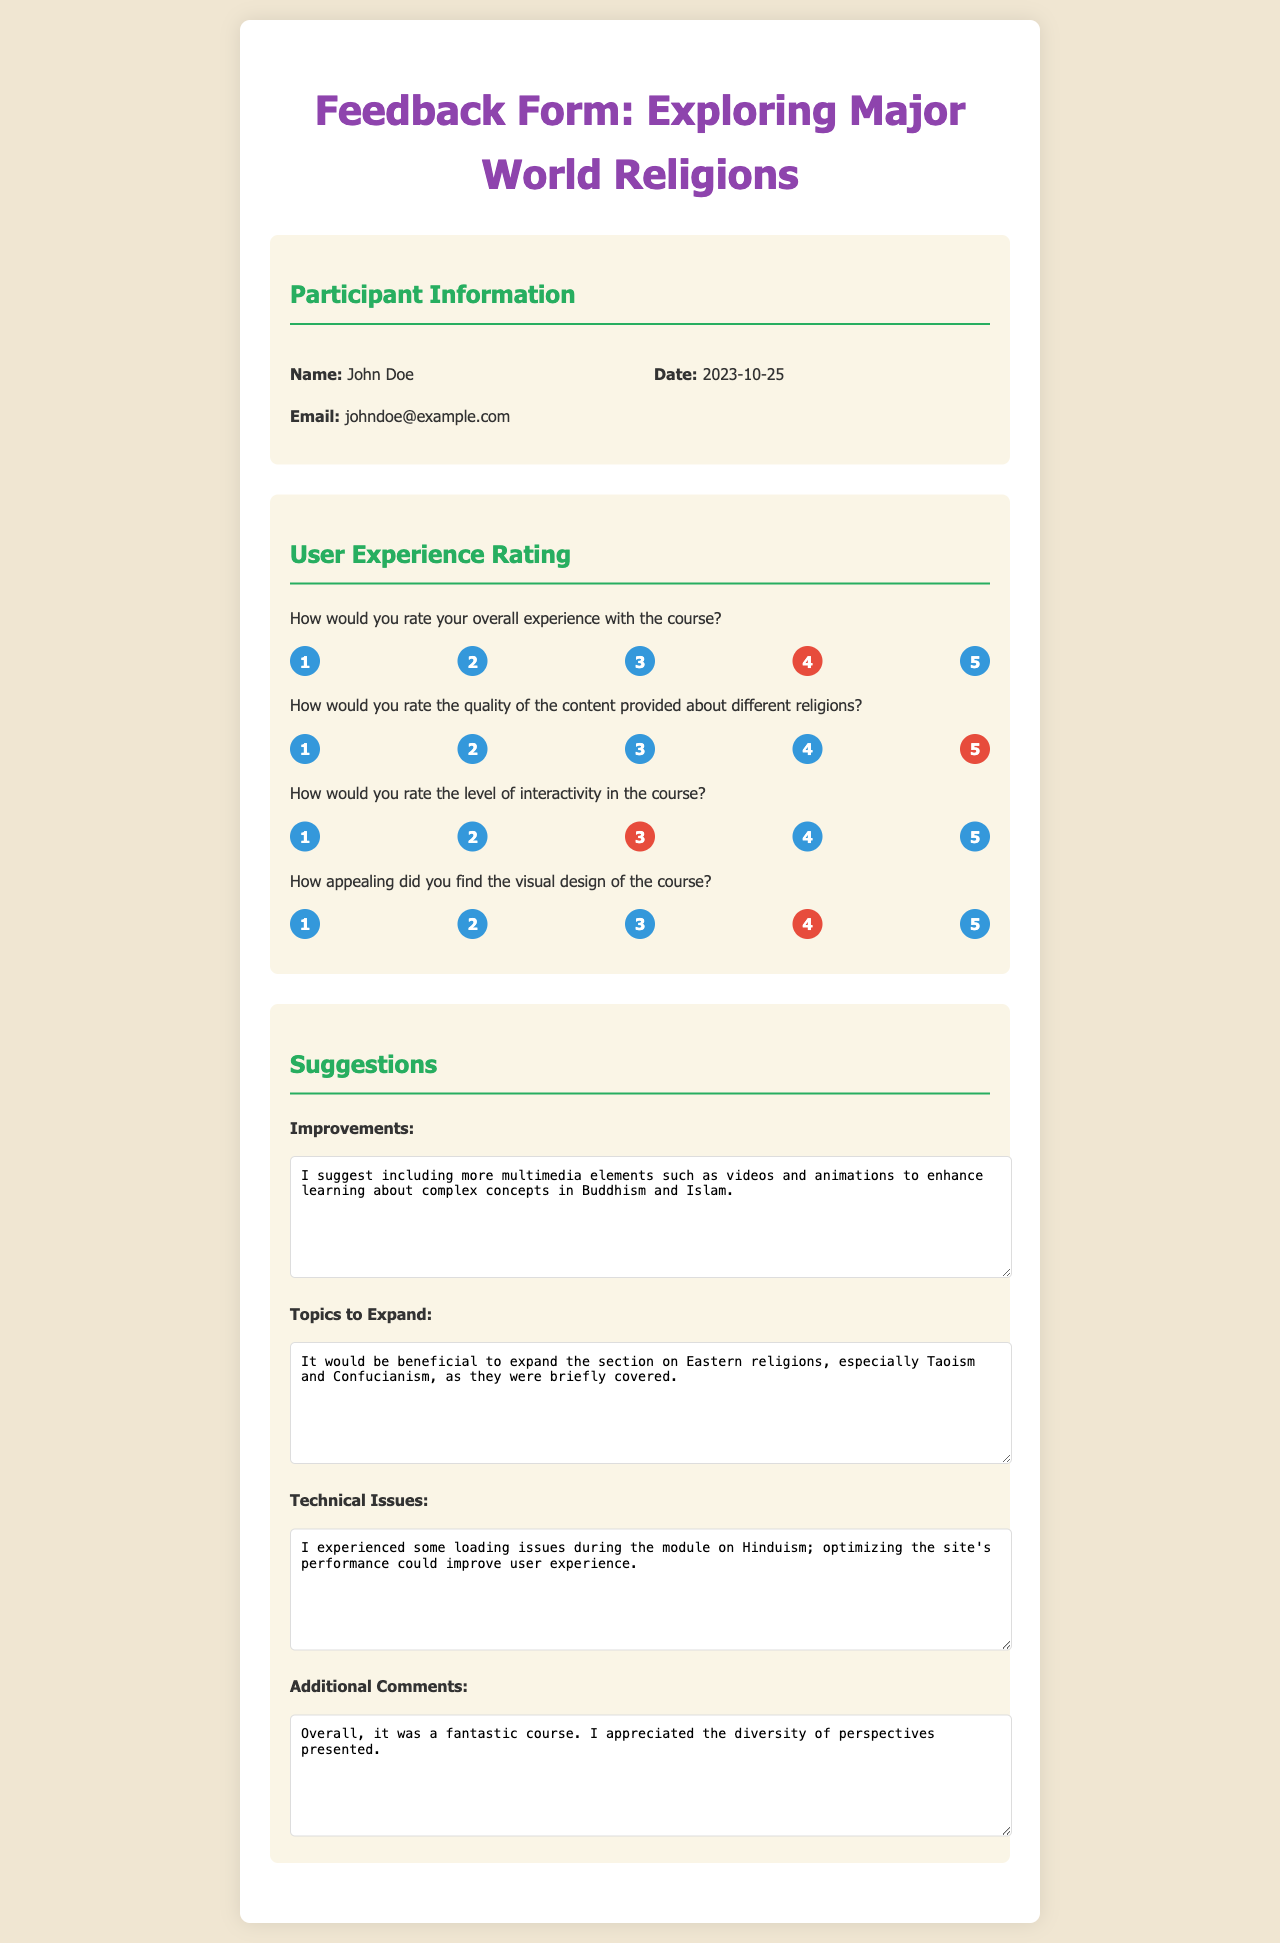What is the name of the participant? The name of the participant is provided in the participant information section of the document.
Answer: John Doe What is the email address of the participant? The email address is listed under the participant information section.
Answer: johndoe@example.com What date was the feedback form submitted? The date is mentioned in the participant information section as well.
Answer: 2023-10-25 How did the participant rate their overall experience with the course? The overall experience rating is indicated by a selected rating option in the user experience section.
Answer: 4 What rating did the participant give for the quality of content? This rating can be found in the user experience rating section.
Answer: 5 What issues did the participant mention in the technical issues section? This information provides insights about the user's experience during the course.
Answer: Loading issues during the module on Hinduism What suggestions did the participant provide for improvements? Suggestions are given in the corresponding section of the document.
Answer: Include more multimedia elements such as videos and animations Which section did the participant suggest expanding? The suggested section to expand is mentioned under topics to expand.
Answer: Eastern religions, especially Taoism and Confucianism What was the participant's overall comment about the course? The additional comments offer insights into the participant's general feelings about the course.
Answer: It was a fantastic course 